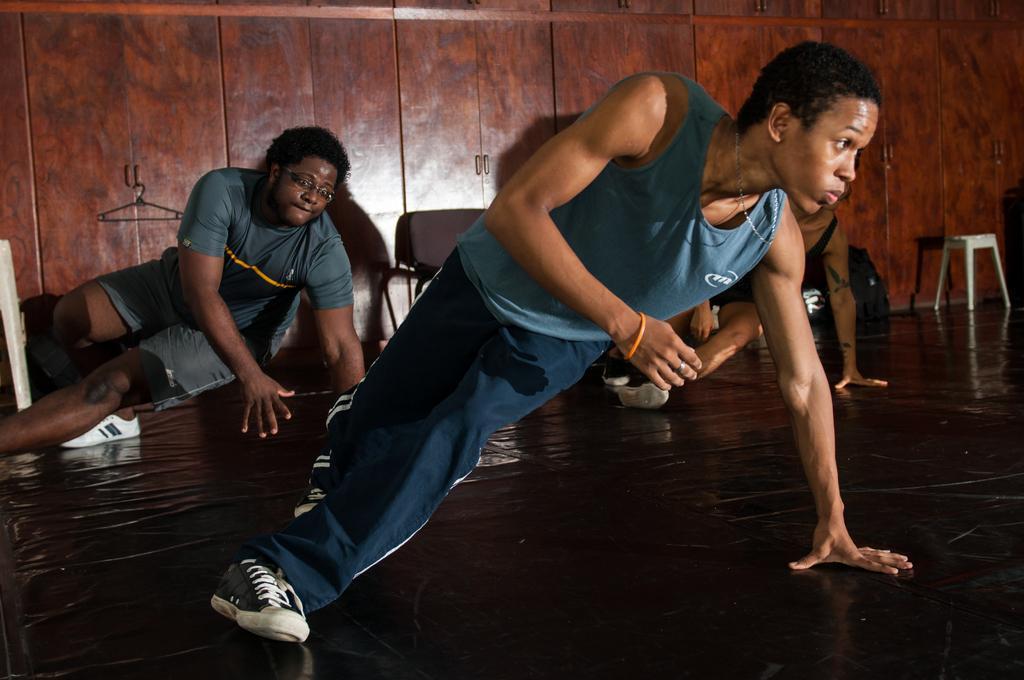Could you give a brief overview of what you see in this image? In this image there are persons dancing. In the background there is a stool and there are objects which are brown and white in colour and there are cupboards. 